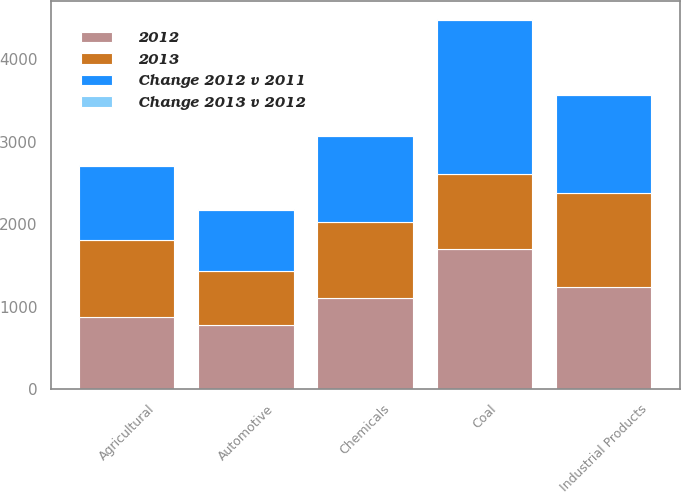Convert chart to OTSL. <chart><loc_0><loc_0><loc_500><loc_500><stacked_bar_chart><ecel><fcel>Agricultural<fcel>Automotive<fcel>Chemicals<fcel>Coal<fcel>Industrial Products<nl><fcel>2012<fcel>874<fcel>781<fcel>1103<fcel>1703<fcel>1236<nl><fcel>Change 2012 v 2011<fcel>900<fcel>738<fcel>1042<fcel>1871<fcel>1185<nl><fcel>2013<fcel>934<fcel>653<fcel>921<fcel>900<fcel>1146<nl><fcel>Change 2013 v 2012<fcel>3<fcel>6<fcel>6<fcel>9<fcel>4<nl></chart> 